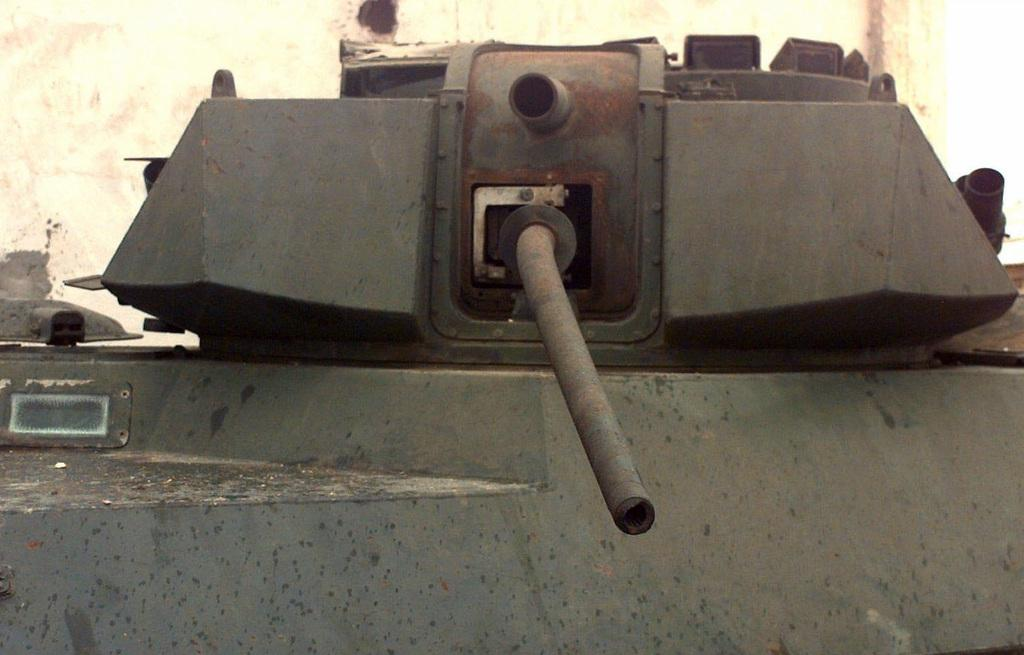What object in the image can be used as a weapon? There is a weapon in the image, but its specific type is not mentioned. What is located at the top of the image? There is a wall at the top of the image. What type of arithmetic problem is being solved on the wall in the image? There is no arithmetic problem visible on the wall in the image. Who is the achiever being offered the weapon in the image? There is no person or achiever mentioned in the image, and the weapon is not being offered to anyone. 